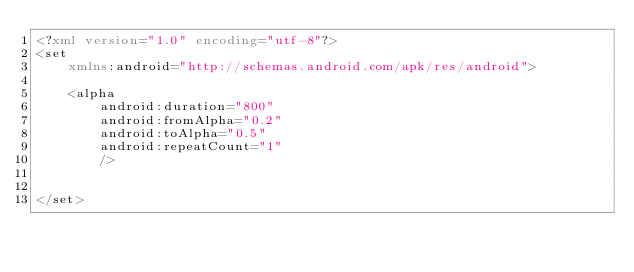Convert code to text. <code><loc_0><loc_0><loc_500><loc_500><_XML_><?xml version="1.0" encoding="utf-8"?>
<set
    xmlns:android="http://schemas.android.com/apk/res/android">

    <alpha
        android:duration="800"
        android:fromAlpha="0.2"
        android:toAlpha="0.5"
        android:repeatCount="1"
        />
    

</set>
</code> 